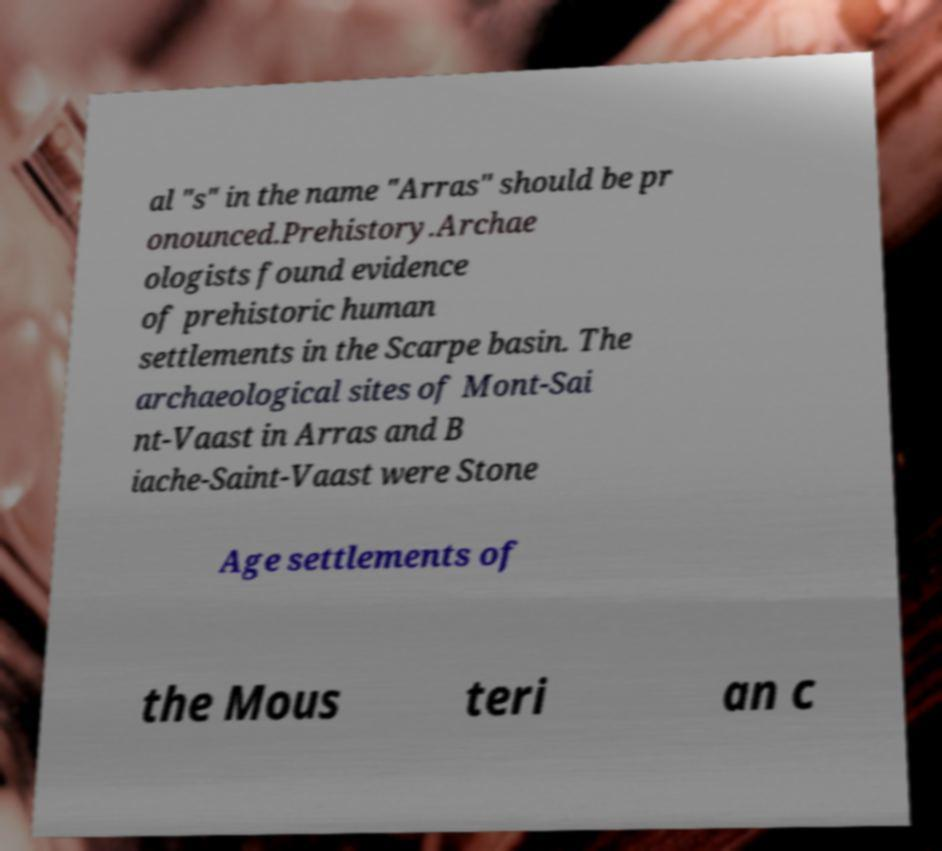Please read and relay the text visible in this image. What does it say? al "s" in the name "Arras" should be pr onounced.Prehistory.Archae ologists found evidence of prehistoric human settlements in the Scarpe basin. The archaeological sites of Mont-Sai nt-Vaast in Arras and B iache-Saint-Vaast were Stone Age settlements of the Mous teri an c 